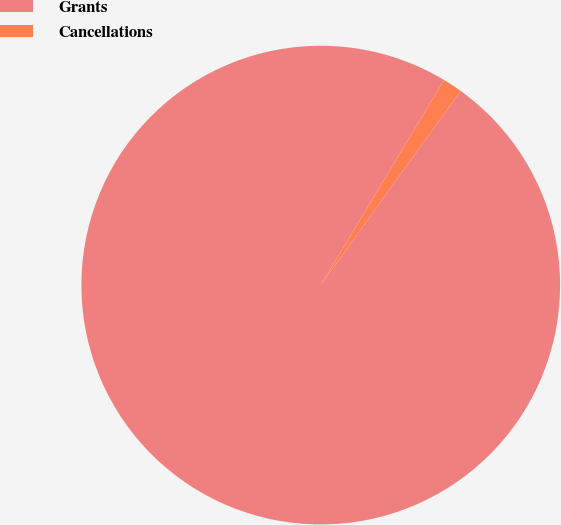Convert chart. <chart><loc_0><loc_0><loc_500><loc_500><pie_chart><fcel>Grants<fcel>Cancellations<nl><fcel>98.68%<fcel>1.32%<nl></chart> 